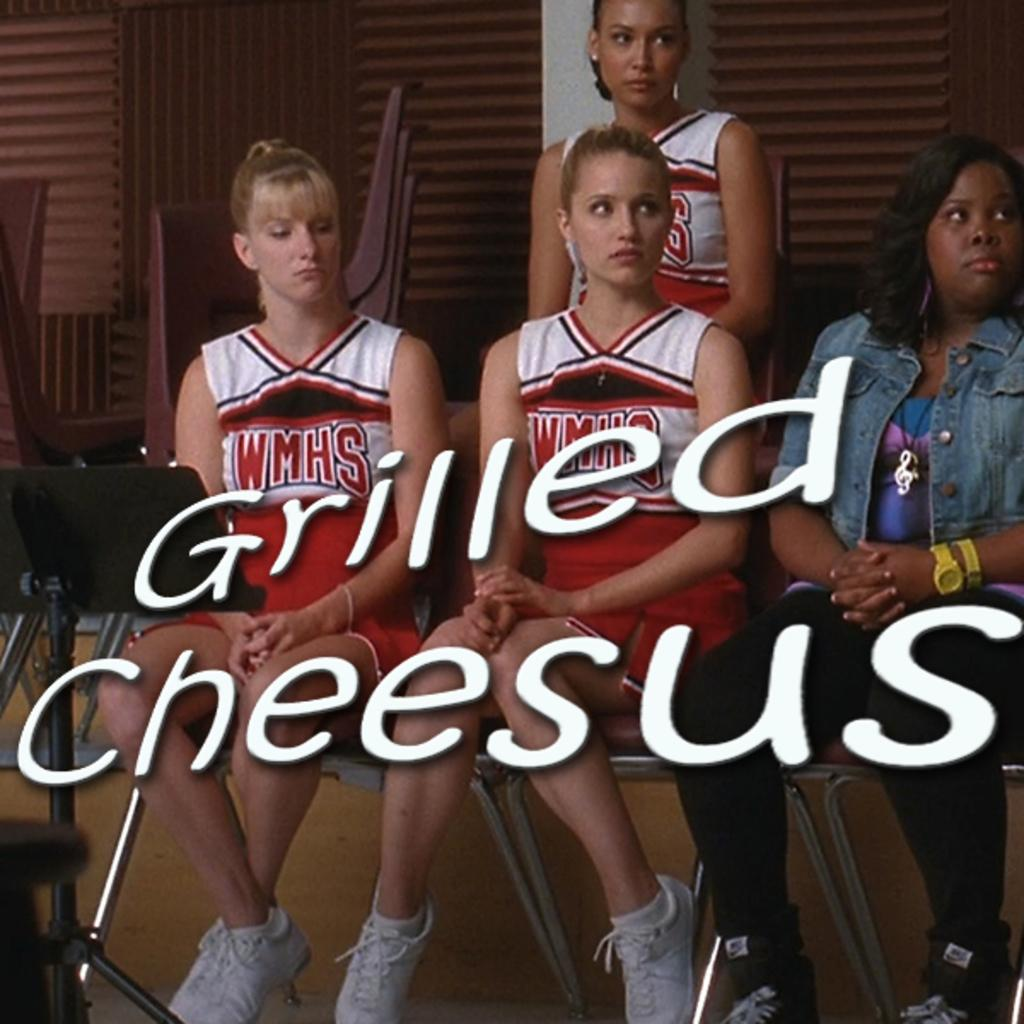<image>
Offer a succinct explanation of the picture presented. Several girls are wearing cheerleading outfits reading WMHS while looking at something. 